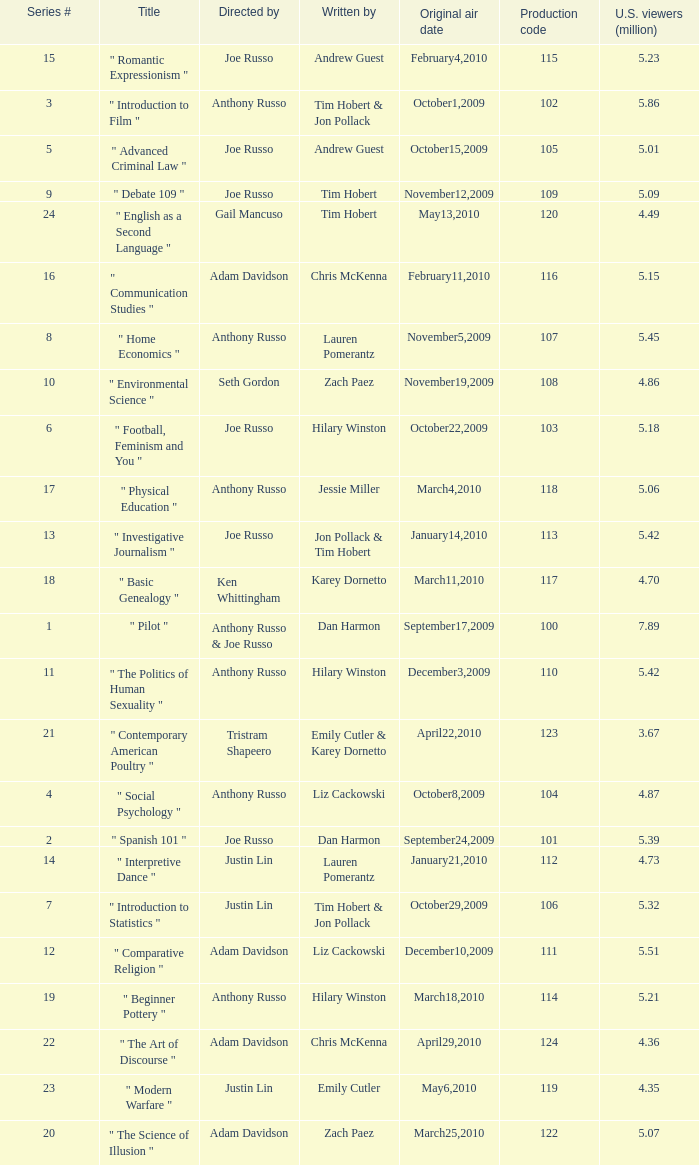How many episodes had a production code 120? 1.0. 